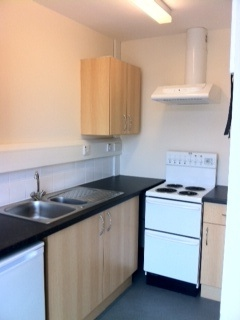Describe the objects in this image and their specific colors. I can see oven in tan, lightblue, black, and darkgray tones and sink in tan, gray, and black tones in this image. 